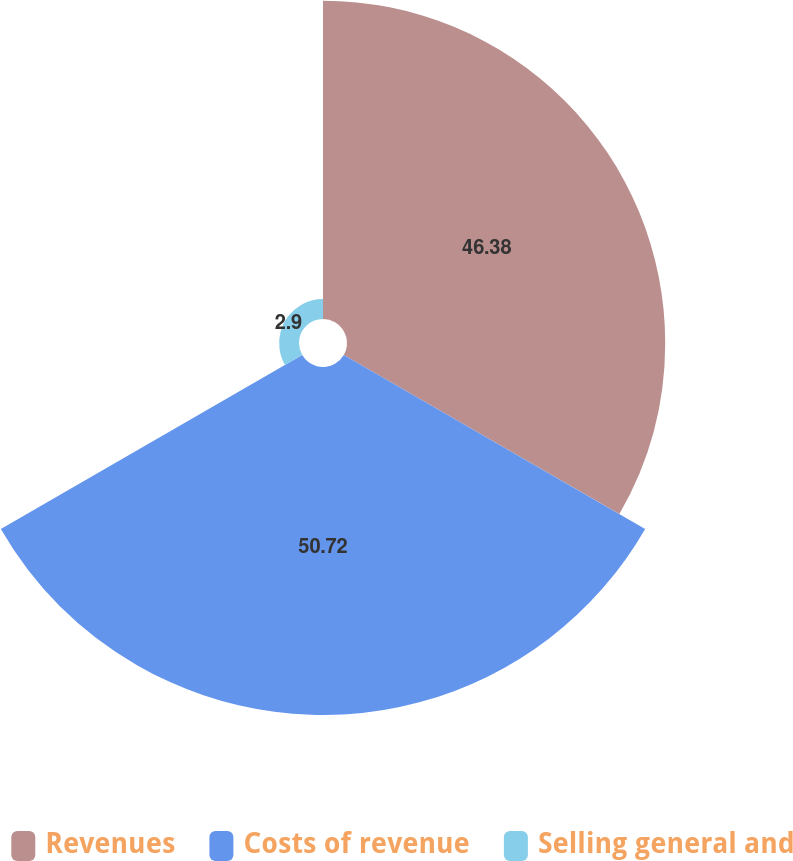Convert chart to OTSL. <chart><loc_0><loc_0><loc_500><loc_500><pie_chart><fcel>Revenues<fcel>Costs of revenue<fcel>Selling general and<nl><fcel>46.38%<fcel>50.72%<fcel>2.9%<nl></chart> 